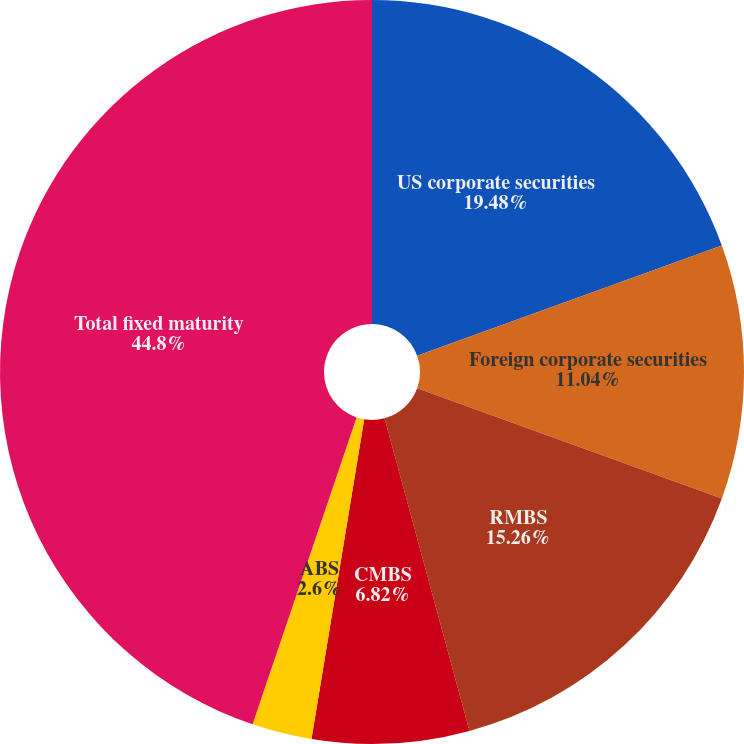Convert chart. <chart><loc_0><loc_0><loc_500><loc_500><pie_chart><fcel>US corporate securities<fcel>Foreign corporate securities<fcel>RMBS<fcel>CMBS<fcel>ABS<fcel>Total fixed maturity<nl><fcel>19.48%<fcel>11.04%<fcel>15.26%<fcel>6.82%<fcel>2.6%<fcel>44.8%<nl></chart> 